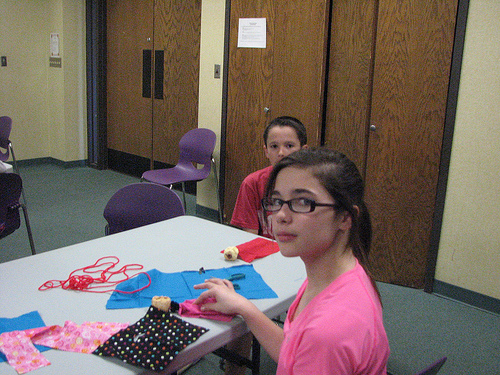<image>
Is there a cloth on the table? Yes. Looking at the image, I can see the cloth is positioned on top of the table, with the table providing support. 